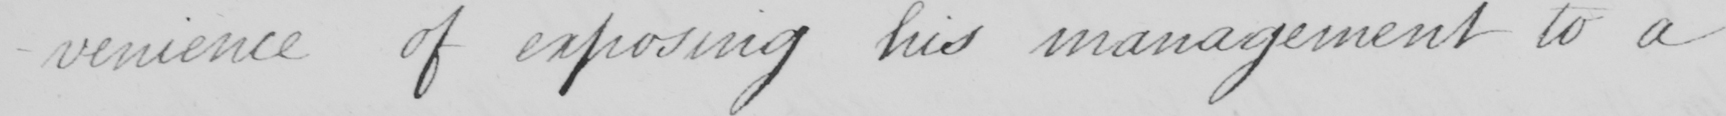Transcribe the text shown in this historical manuscript line. -ience of exposing his management to a 